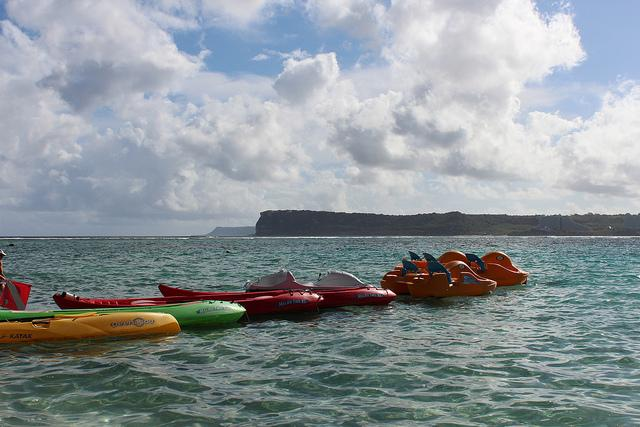What is one of the biggest risks in this environment? drowning 